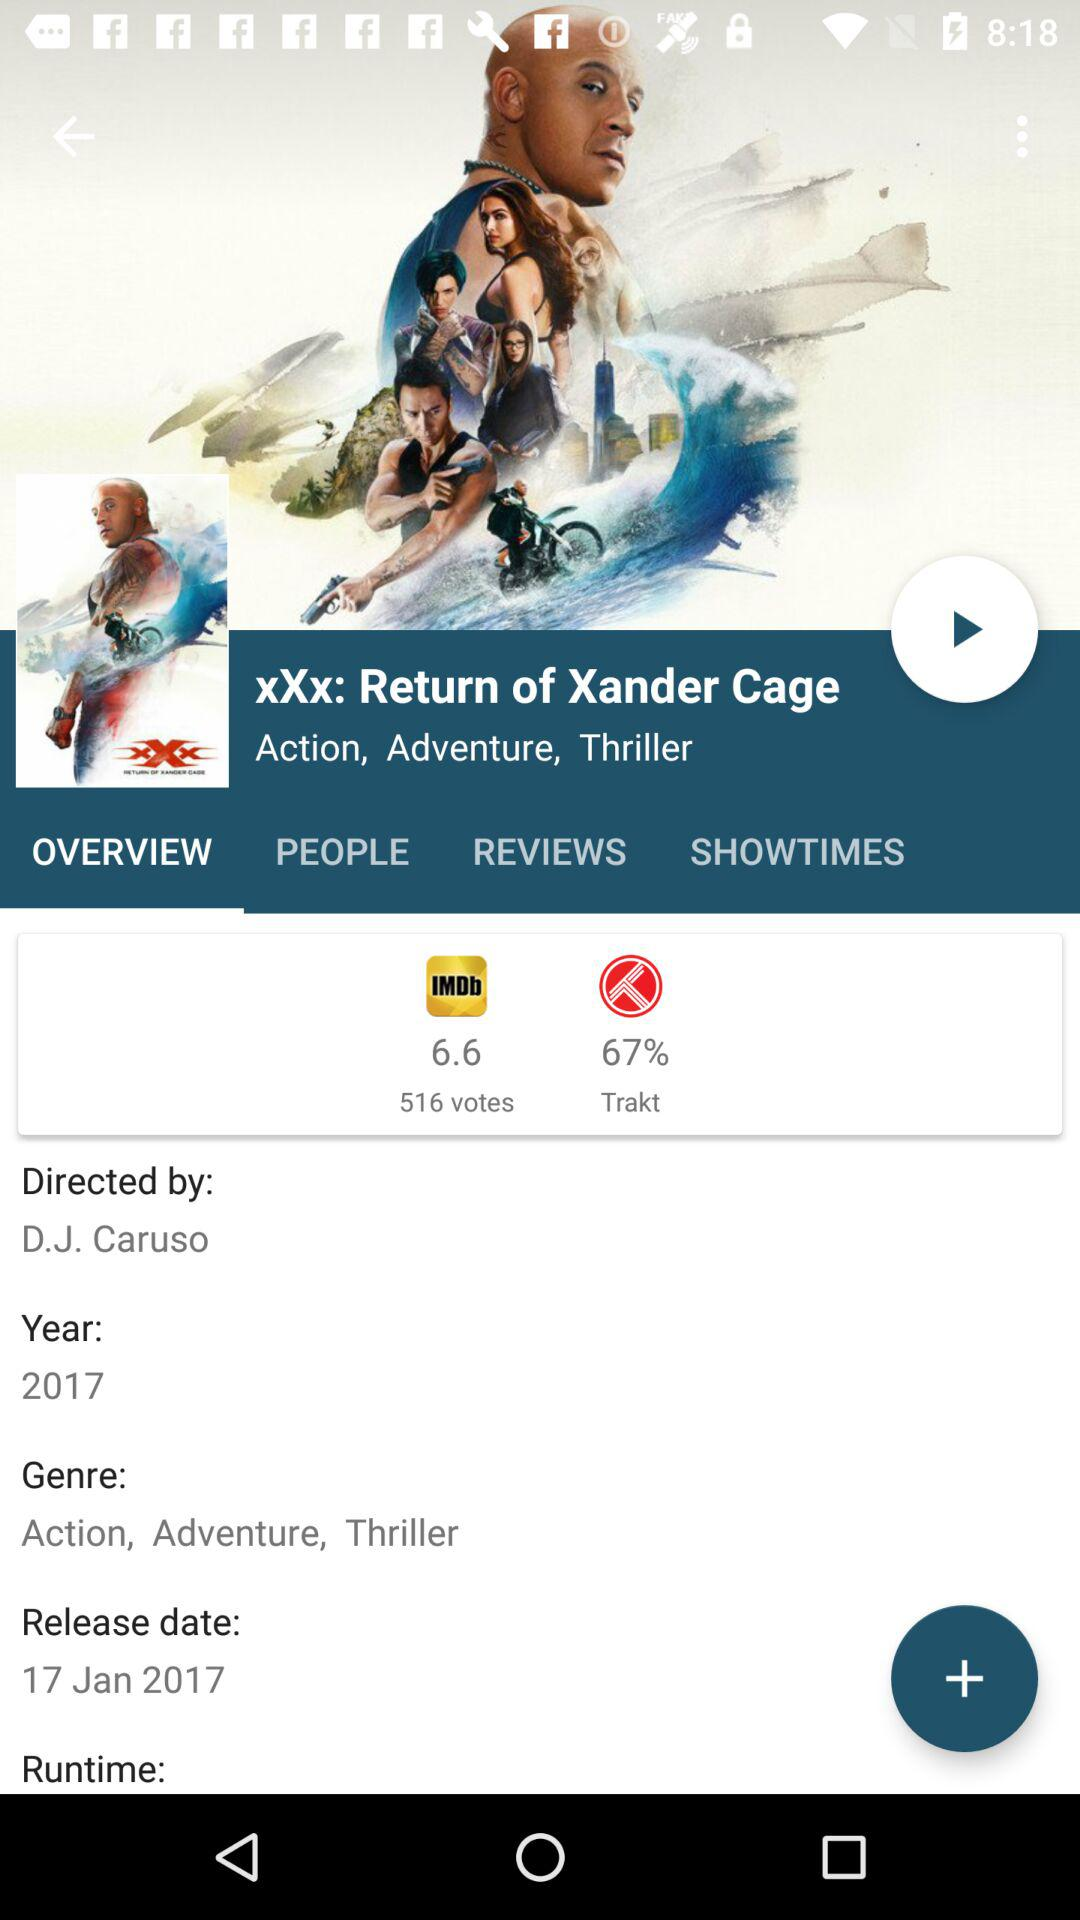What are the genres of the movie? The genres of the movie are Action, Adventure, Thriller. 